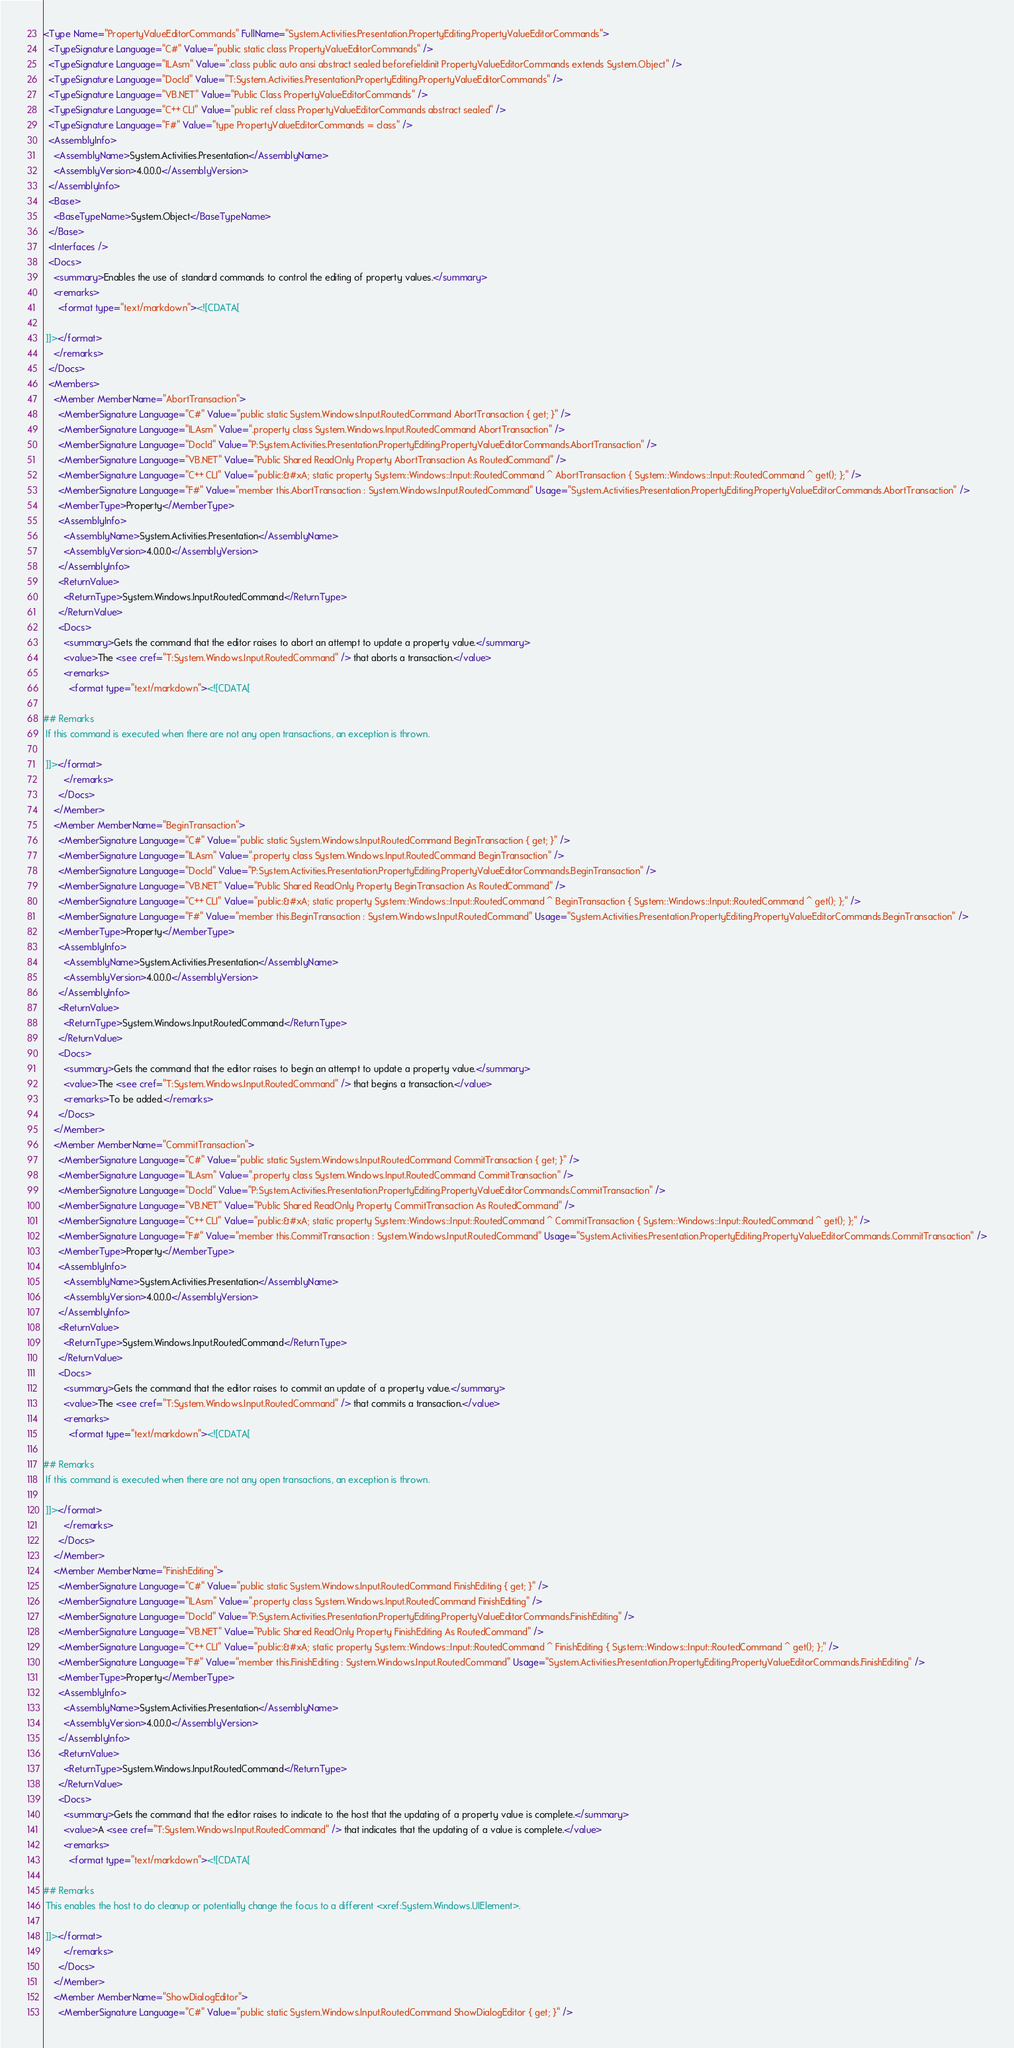<code> <loc_0><loc_0><loc_500><loc_500><_XML_><Type Name="PropertyValueEditorCommands" FullName="System.Activities.Presentation.PropertyEditing.PropertyValueEditorCommands">
  <TypeSignature Language="C#" Value="public static class PropertyValueEditorCommands" />
  <TypeSignature Language="ILAsm" Value=".class public auto ansi abstract sealed beforefieldinit PropertyValueEditorCommands extends System.Object" />
  <TypeSignature Language="DocId" Value="T:System.Activities.Presentation.PropertyEditing.PropertyValueEditorCommands" />
  <TypeSignature Language="VB.NET" Value="Public Class PropertyValueEditorCommands" />
  <TypeSignature Language="C++ CLI" Value="public ref class PropertyValueEditorCommands abstract sealed" />
  <TypeSignature Language="F#" Value="type PropertyValueEditorCommands = class" />
  <AssemblyInfo>
    <AssemblyName>System.Activities.Presentation</AssemblyName>
    <AssemblyVersion>4.0.0.0</AssemblyVersion>
  </AssemblyInfo>
  <Base>
    <BaseTypeName>System.Object</BaseTypeName>
  </Base>
  <Interfaces />
  <Docs>
    <summary>Enables the use of standard commands to control the editing of property values.</summary>
    <remarks>
      <format type="text/markdown"><![CDATA[  
  
 ]]></format>
    </remarks>
  </Docs>
  <Members>
    <Member MemberName="AbortTransaction">
      <MemberSignature Language="C#" Value="public static System.Windows.Input.RoutedCommand AbortTransaction { get; }" />
      <MemberSignature Language="ILAsm" Value=".property class System.Windows.Input.RoutedCommand AbortTransaction" />
      <MemberSignature Language="DocId" Value="P:System.Activities.Presentation.PropertyEditing.PropertyValueEditorCommands.AbortTransaction" />
      <MemberSignature Language="VB.NET" Value="Public Shared ReadOnly Property AbortTransaction As RoutedCommand" />
      <MemberSignature Language="C++ CLI" Value="public:&#xA; static property System::Windows::Input::RoutedCommand ^ AbortTransaction { System::Windows::Input::RoutedCommand ^ get(); };" />
      <MemberSignature Language="F#" Value="member this.AbortTransaction : System.Windows.Input.RoutedCommand" Usage="System.Activities.Presentation.PropertyEditing.PropertyValueEditorCommands.AbortTransaction" />
      <MemberType>Property</MemberType>
      <AssemblyInfo>
        <AssemblyName>System.Activities.Presentation</AssemblyName>
        <AssemblyVersion>4.0.0.0</AssemblyVersion>
      </AssemblyInfo>
      <ReturnValue>
        <ReturnType>System.Windows.Input.RoutedCommand</ReturnType>
      </ReturnValue>
      <Docs>
        <summary>Gets the command that the editor raises to abort an attempt to update a property value.</summary>
        <value>The <see cref="T:System.Windows.Input.RoutedCommand" /> that aborts a transaction.</value>
        <remarks>
          <format type="text/markdown"><![CDATA[  
  
## Remarks  
 If this command is executed when there are not any open transactions, an exception is thrown.  
  
 ]]></format>
        </remarks>
      </Docs>
    </Member>
    <Member MemberName="BeginTransaction">
      <MemberSignature Language="C#" Value="public static System.Windows.Input.RoutedCommand BeginTransaction { get; }" />
      <MemberSignature Language="ILAsm" Value=".property class System.Windows.Input.RoutedCommand BeginTransaction" />
      <MemberSignature Language="DocId" Value="P:System.Activities.Presentation.PropertyEditing.PropertyValueEditorCommands.BeginTransaction" />
      <MemberSignature Language="VB.NET" Value="Public Shared ReadOnly Property BeginTransaction As RoutedCommand" />
      <MemberSignature Language="C++ CLI" Value="public:&#xA; static property System::Windows::Input::RoutedCommand ^ BeginTransaction { System::Windows::Input::RoutedCommand ^ get(); };" />
      <MemberSignature Language="F#" Value="member this.BeginTransaction : System.Windows.Input.RoutedCommand" Usage="System.Activities.Presentation.PropertyEditing.PropertyValueEditorCommands.BeginTransaction" />
      <MemberType>Property</MemberType>
      <AssemblyInfo>
        <AssemblyName>System.Activities.Presentation</AssemblyName>
        <AssemblyVersion>4.0.0.0</AssemblyVersion>
      </AssemblyInfo>
      <ReturnValue>
        <ReturnType>System.Windows.Input.RoutedCommand</ReturnType>
      </ReturnValue>
      <Docs>
        <summary>Gets the command that the editor raises to begin an attempt to update a property value.</summary>
        <value>The <see cref="T:System.Windows.Input.RoutedCommand" /> that begins a transaction.</value>
        <remarks>To be added.</remarks>
      </Docs>
    </Member>
    <Member MemberName="CommitTransaction">
      <MemberSignature Language="C#" Value="public static System.Windows.Input.RoutedCommand CommitTransaction { get; }" />
      <MemberSignature Language="ILAsm" Value=".property class System.Windows.Input.RoutedCommand CommitTransaction" />
      <MemberSignature Language="DocId" Value="P:System.Activities.Presentation.PropertyEditing.PropertyValueEditorCommands.CommitTransaction" />
      <MemberSignature Language="VB.NET" Value="Public Shared ReadOnly Property CommitTransaction As RoutedCommand" />
      <MemberSignature Language="C++ CLI" Value="public:&#xA; static property System::Windows::Input::RoutedCommand ^ CommitTransaction { System::Windows::Input::RoutedCommand ^ get(); };" />
      <MemberSignature Language="F#" Value="member this.CommitTransaction : System.Windows.Input.RoutedCommand" Usage="System.Activities.Presentation.PropertyEditing.PropertyValueEditorCommands.CommitTransaction" />
      <MemberType>Property</MemberType>
      <AssemblyInfo>
        <AssemblyName>System.Activities.Presentation</AssemblyName>
        <AssemblyVersion>4.0.0.0</AssemblyVersion>
      </AssemblyInfo>
      <ReturnValue>
        <ReturnType>System.Windows.Input.RoutedCommand</ReturnType>
      </ReturnValue>
      <Docs>
        <summary>Gets the command that the editor raises to commit an update of a property value.</summary>
        <value>The <see cref="T:System.Windows.Input.RoutedCommand" /> that commits a transaction.</value>
        <remarks>
          <format type="text/markdown"><![CDATA[  
  
## Remarks  
 If this command is executed when there are not any open transactions, an exception is thrown.  
  
 ]]></format>
        </remarks>
      </Docs>
    </Member>
    <Member MemberName="FinishEditing">
      <MemberSignature Language="C#" Value="public static System.Windows.Input.RoutedCommand FinishEditing { get; }" />
      <MemberSignature Language="ILAsm" Value=".property class System.Windows.Input.RoutedCommand FinishEditing" />
      <MemberSignature Language="DocId" Value="P:System.Activities.Presentation.PropertyEditing.PropertyValueEditorCommands.FinishEditing" />
      <MemberSignature Language="VB.NET" Value="Public Shared ReadOnly Property FinishEditing As RoutedCommand" />
      <MemberSignature Language="C++ CLI" Value="public:&#xA; static property System::Windows::Input::RoutedCommand ^ FinishEditing { System::Windows::Input::RoutedCommand ^ get(); };" />
      <MemberSignature Language="F#" Value="member this.FinishEditing : System.Windows.Input.RoutedCommand" Usage="System.Activities.Presentation.PropertyEditing.PropertyValueEditorCommands.FinishEditing" />
      <MemberType>Property</MemberType>
      <AssemblyInfo>
        <AssemblyName>System.Activities.Presentation</AssemblyName>
        <AssemblyVersion>4.0.0.0</AssemblyVersion>
      </AssemblyInfo>
      <ReturnValue>
        <ReturnType>System.Windows.Input.RoutedCommand</ReturnType>
      </ReturnValue>
      <Docs>
        <summary>Gets the command that the editor raises to indicate to the host that the updating of a property value is complete.</summary>
        <value>A <see cref="T:System.Windows.Input.RoutedCommand" /> that indicates that the updating of a value is complete.</value>
        <remarks>
          <format type="text/markdown"><![CDATA[  
  
## Remarks  
 This enables the host to do cleanup or potentially change the focus to a different <xref:System.Windows.UIElement>.  
  
 ]]></format>
        </remarks>
      </Docs>
    </Member>
    <Member MemberName="ShowDialogEditor">
      <MemberSignature Language="C#" Value="public static System.Windows.Input.RoutedCommand ShowDialogEditor { get; }" /></code> 